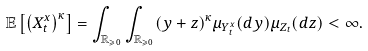Convert formula to latex. <formula><loc_0><loc_0><loc_500><loc_500>\mathbb { E } \left [ \left ( X _ { t } ^ { x } \right ) ^ { \kappa } \right ] = \int _ { \mathbb { R } _ { \geqslant 0 } } \int _ { \mathbb { R } _ { \geqslant 0 } } ( y + z ) ^ { \kappa } \mu _ { Y _ { t } ^ { x } } ( d y ) \mu _ { Z _ { t } } ( d z ) < \infty .</formula> 